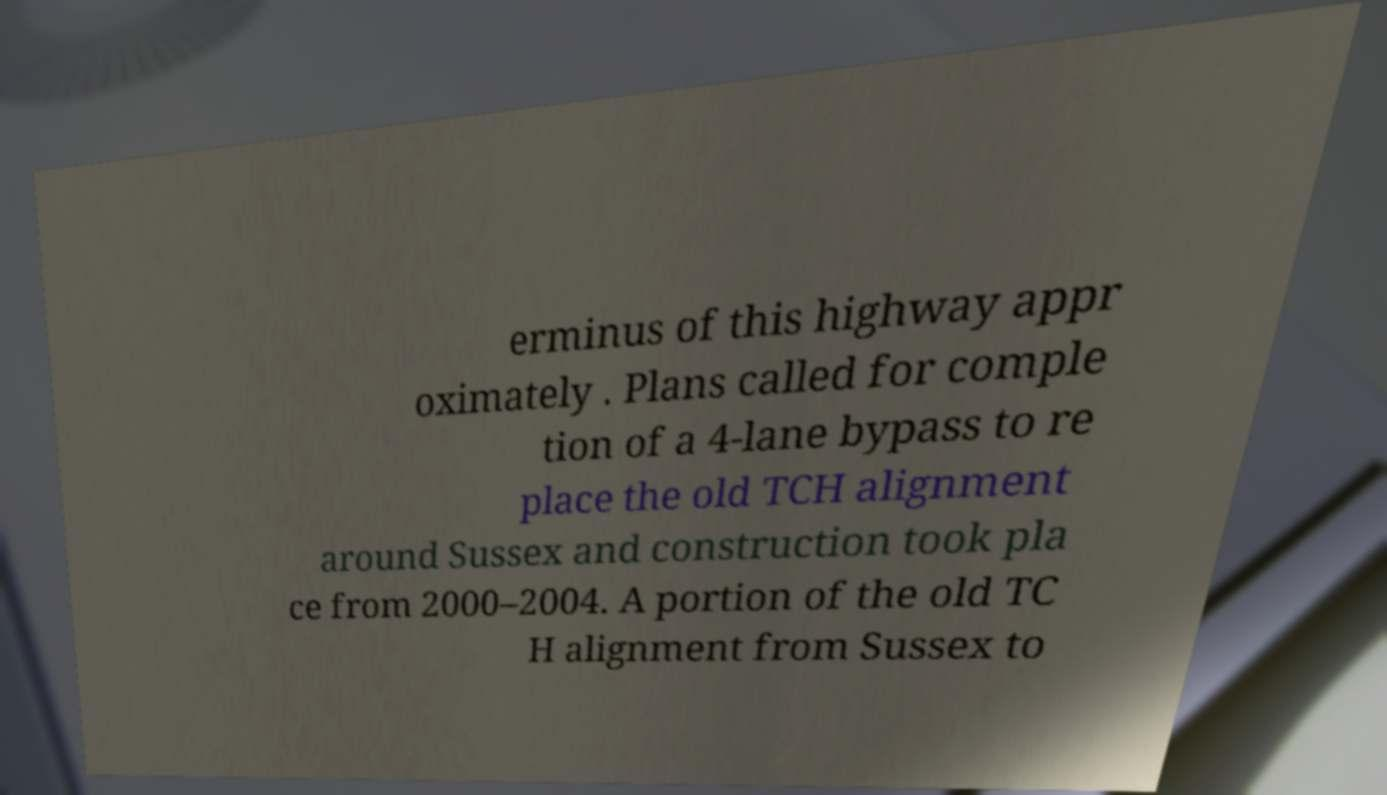Can you accurately transcribe the text from the provided image for me? erminus of this highway appr oximately . Plans called for comple tion of a 4-lane bypass to re place the old TCH alignment around Sussex and construction took pla ce from 2000–2004. A portion of the old TC H alignment from Sussex to 